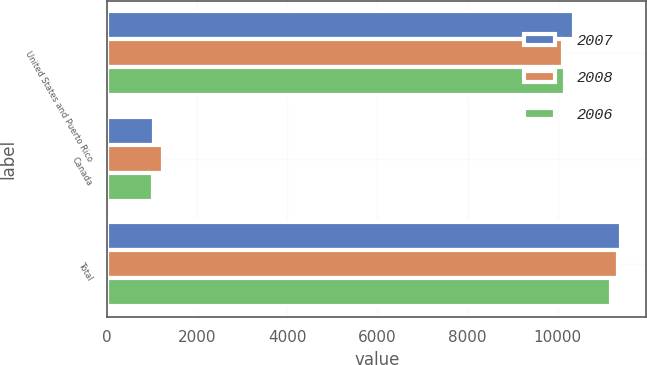<chart> <loc_0><loc_0><loc_500><loc_500><stacked_bar_chart><ecel><fcel>United States and Puerto Rico<fcel>Canada<fcel>Total<nl><fcel>2007<fcel>10355<fcel>1047<fcel>11402<nl><fcel>2008<fcel>10122<fcel>1229<fcel>11351<nl><fcel>2006<fcel>10163<fcel>1016<fcel>11179<nl></chart> 